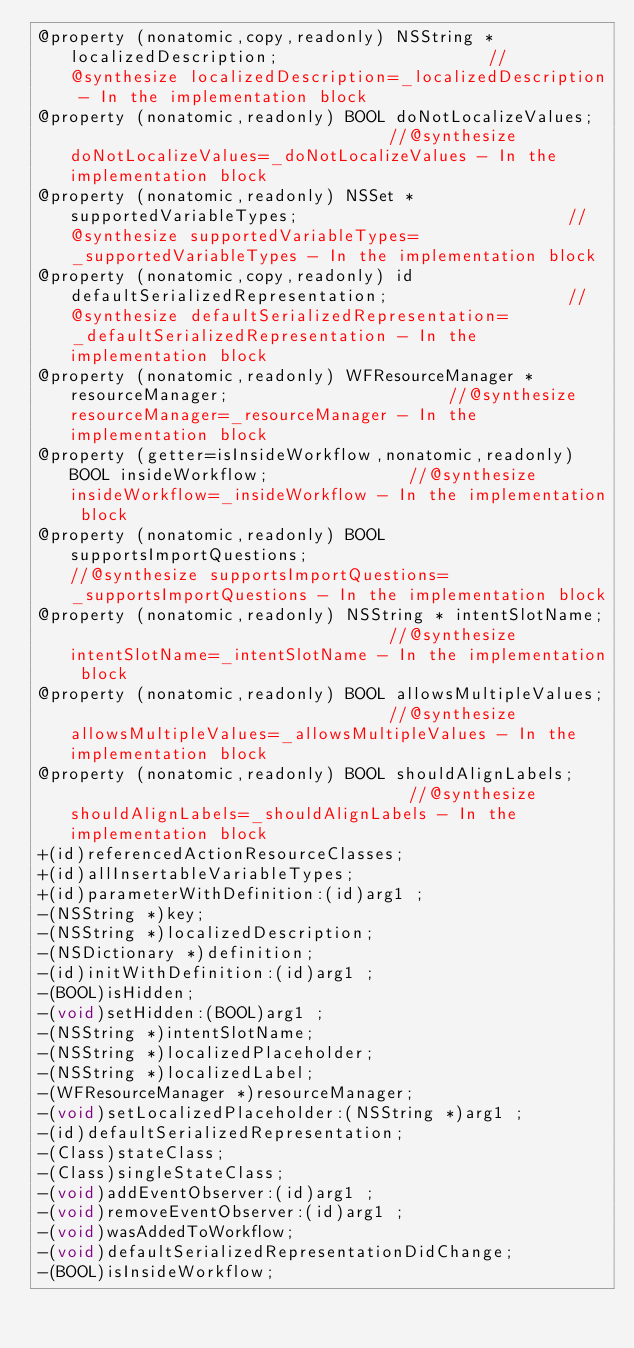Convert code to text. <code><loc_0><loc_0><loc_500><loc_500><_C_>@property (nonatomic,copy,readonly) NSString * localizedDescription;                     //@synthesize localizedDescription=_localizedDescription - In the implementation block
@property (nonatomic,readonly) BOOL doNotLocalizeValues;                                 //@synthesize doNotLocalizeValues=_doNotLocalizeValues - In the implementation block
@property (nonatomic,readonly) NSSet * supportedVariableTypes;                           //@synthesize supportedVariableTypes=_supportedVariableTypes - In the implementation block
@property (nonatomic,copy,readonly) id defaultSerializedRepresentation;                  //@synthesize defaultSerializedRepresentation=_defaultSerializedRepresentation - In the implementation block
@property (nonatomic,readonly) WFResourceManager * resourceManager;                      //@synthesize resourceManager=_resourceManager - In the implementation block
@property (getter=isInsideWorkflow,nonatomic,readonly) BOOL insideWorkflow;              //@synthesize insideWorkflow=_insideWorkflow - In the implementation block
@property (nonatomic,readonly) BOOL supportsImportQuestions;                             //@synthesize supportsImportQuestions=_supportsImportQuestions - In the implementation block
@property (nonatomic,readonly) NSString * intentSlotName;                                //@synthesize intentSlotName=_intentSlotName - In the implementation block
@property (nonatomic,readonly) BOOL allowsMultipleValues;                                //@synthesize allowsMultipleValues=_allowsMultipleValues - In the implementation block
@property (nonatomic,readonly) BOOL shouldAlignLabels;                                   //@synthesize shouldAlignLabels=_shouldAlignLabels - In the implementation block
+(id)referencedActionResourceClasses;
+(id)allInsertableVariableTypes;
+(id)parameterWithDefinition:(id)arg1 ;
-(NSString *)key;
-(NSString *)localizedDescription;
-(NSDictionary *)definition;
-(id)initWithDefinition:(id)arg1 ;
-(BOOL)isHidden;
-(void)setHidden:(BOOL)arg1 ;
-(NSString *)intentSlotName;
-(NSString *)localizedPlaceholder;
-(NSString *)localizedLabel;
-(WFResourceManager *)resourceManager;
-(void)setLocalizedPlaceholder:(NSString *)arg1 ;
-(id)defaultSerializedRepresentation;
-(Class)stateClass;
-(Class)singleStateClass;
-(void)addEventObserver:(id)arg1 ;
-(void)removeEventObserver:(id)arg1 ;
-(void)wasAddedToWorkflow;
-(void)defaultSerializedRepresentationDidChange;
-(BOOL)isInsideWorkflow;</code> 